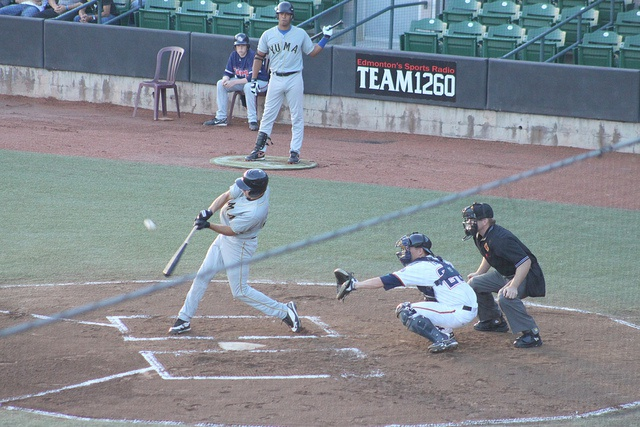Describe the objects in this image and their specific colors. I can see people in blue, darkgray, lightblue, and lightgray tones, people in blue, lightblue, and gray tones, people in blue, gray, black, darkblue, and darkgray tones, chair in blue, teal, and gray tones, and people in blue, lightblue, darkgray, and gray tones in this image. 